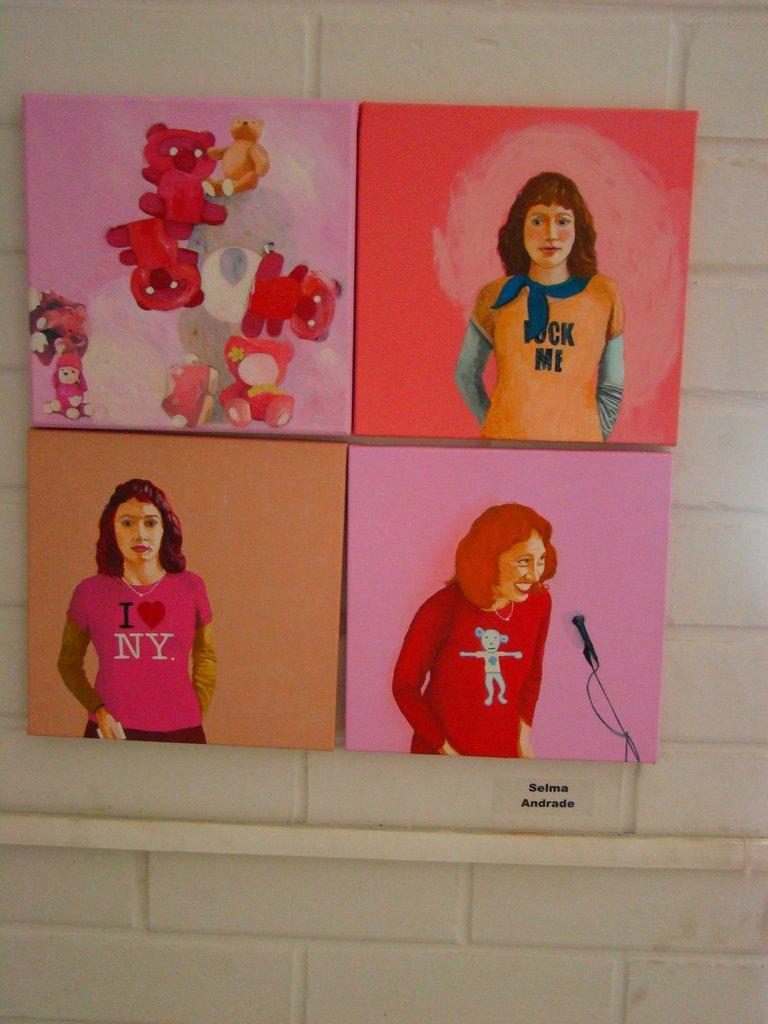Where was the image taken? The image was taken indoors. What can be seen in the background of the image? There is a wall in the background of the image. What is the main subject in the middle of the image? There is a board in the middle of the image. What type of art is displayed on the board? The board contains an art of teddy bears and an art of a girl. Can you see any badges on the girl's uniform in the image? There is no girl's uniform present in the image, as it only features an art of a girl. What type of seashore can be seen in the background of the image? There is no seashore present in the image, as it was taken indoors with a wall in the background. 